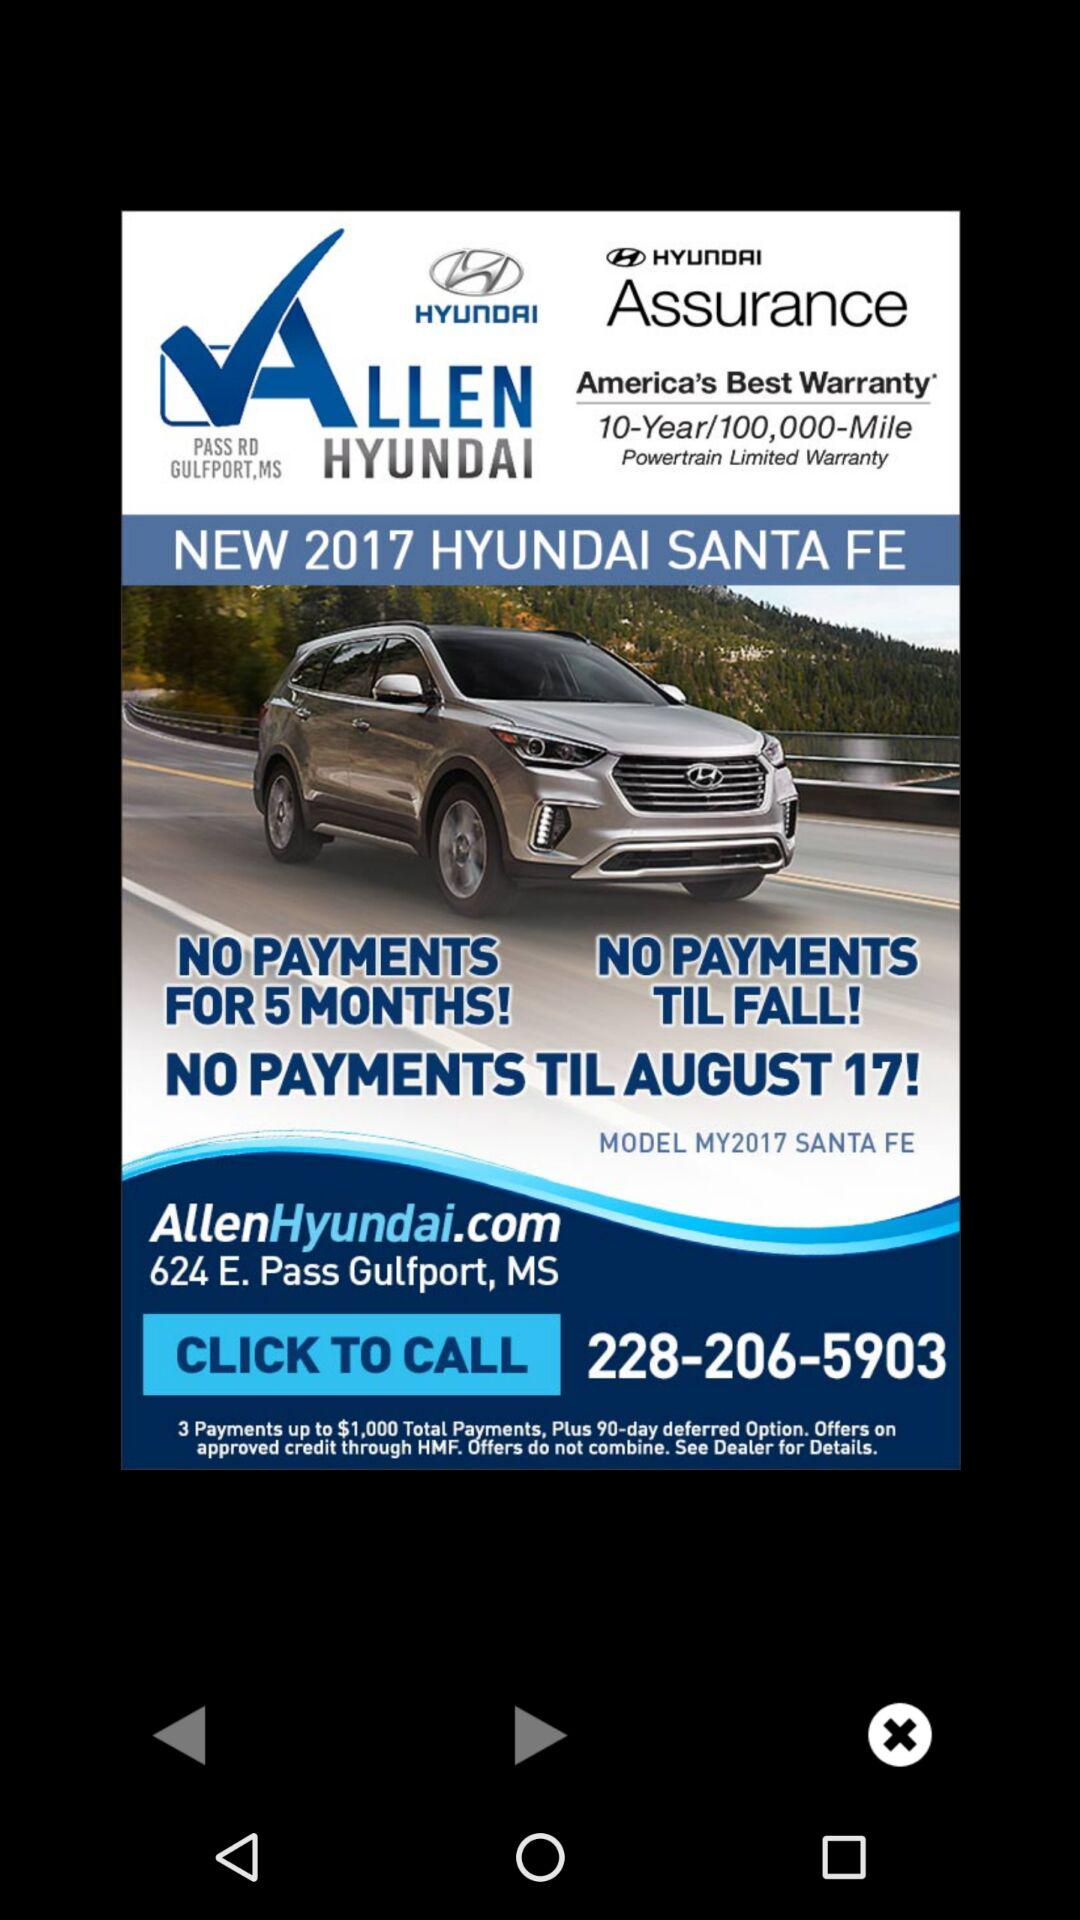How many payments are offered?
Answer the question using a single word or phrase. 3 